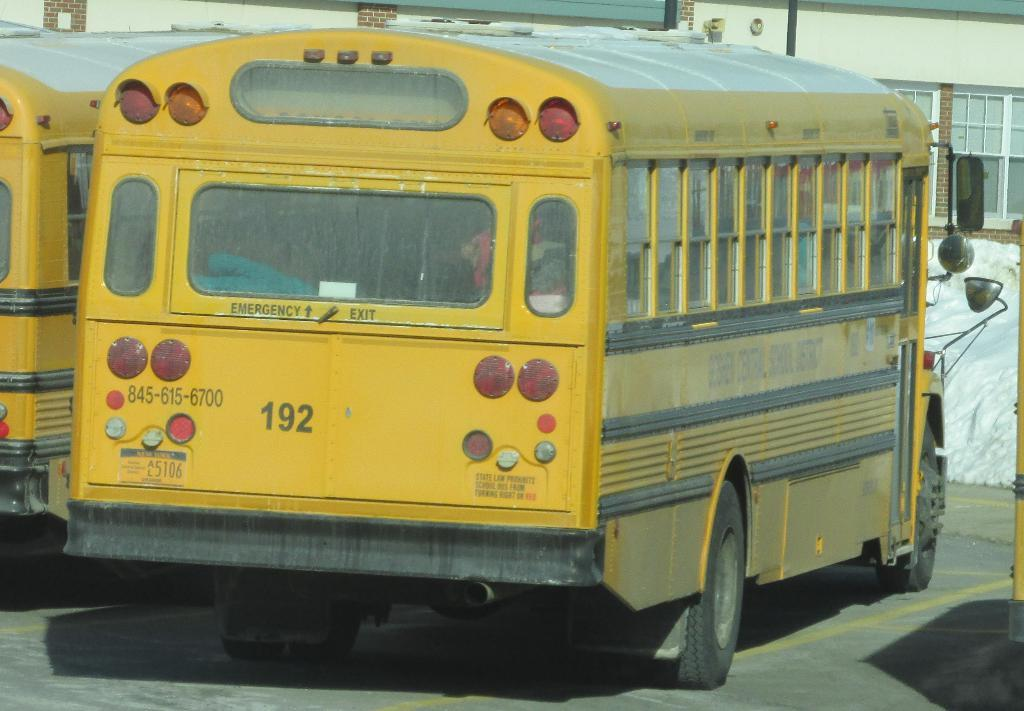<image>
Render a clear and concise summary of the photo. The yellow bus shown is a number 192 bus. 